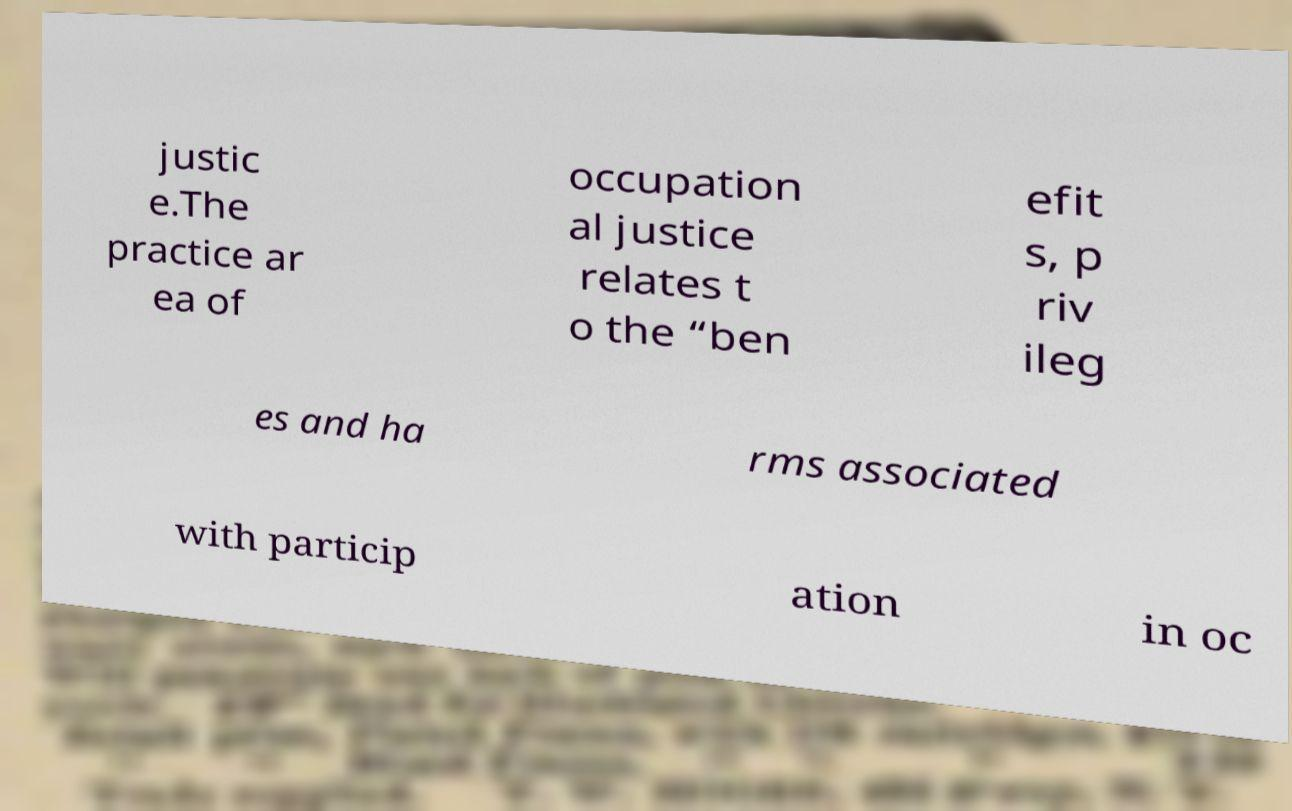For documentation purposes, I need the text within this image transcribed. Could you provide that? justic e.The practice ar ea of occupation al justice relates t o the “ben efit s, p riv ileg es and ha rms associated with particip ation in oc 